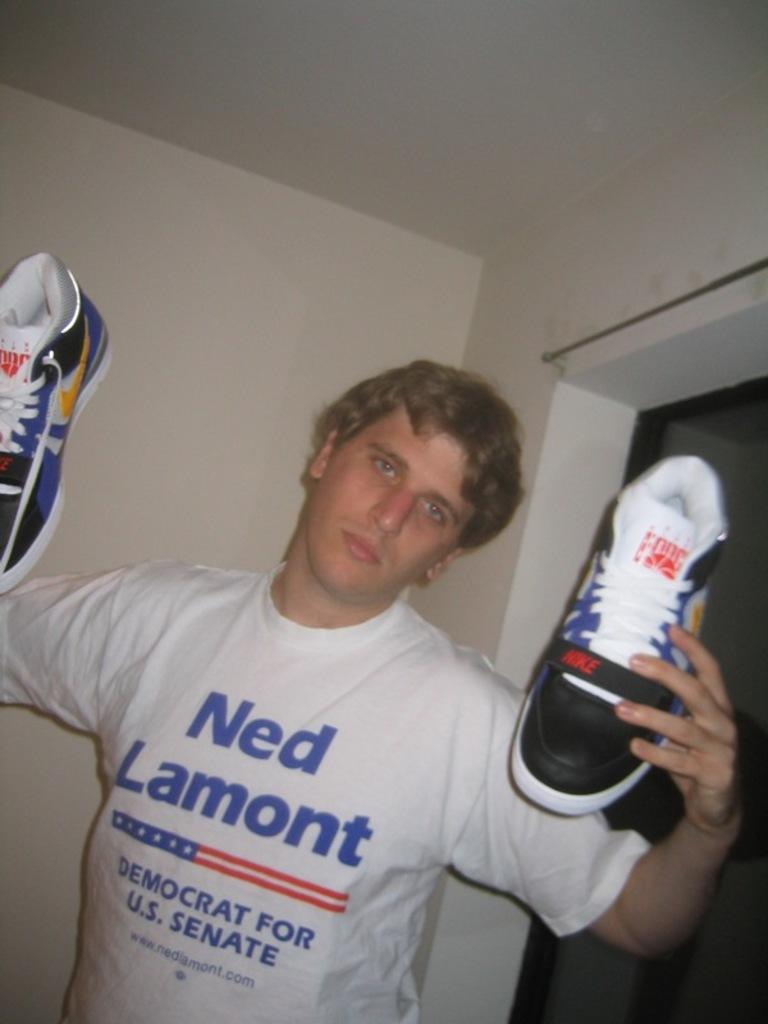<image>
Relay a brief, clear account of the picture shown. A man in a Ned Lamont shirt holds his sneakers up. 